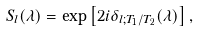<formula> <loc_0><loc_0><loc_500><loc_500>S _ { l } ( \lambda ) = \exp \left [ 2 i \delta _ { l ; T _ { 1 } / T _ { 2 } } ( \lambda ) \right ] ,</formula> 